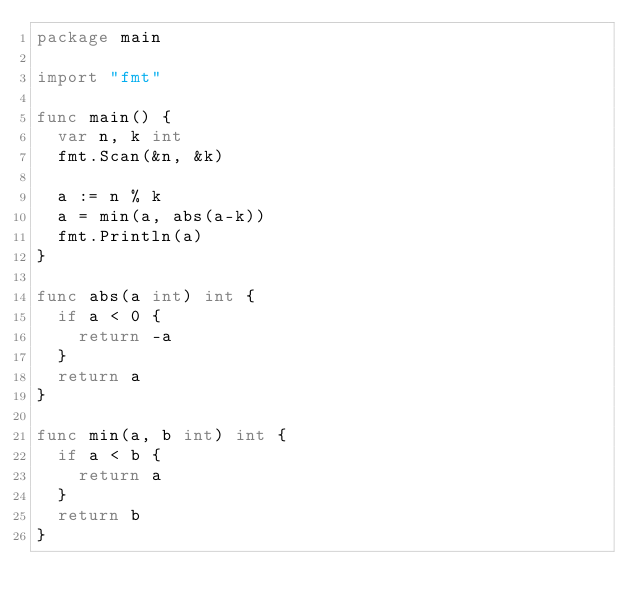Convert code to text. <code><loc_0><loc_0><loc_500><loc_500><_Go_>package main

import "fmt"

func main() {
	var n, k int
	fmt.Scan(&n, &k)

	a := n % k
	a = min(a, abs(a-k))
	fmt.Println(a)
}

func abs(a int) int {
	if a < 0 {
		return -a
	}
	return a
}

func min(a, b int) int {
	if a < b {
		return a
	}
	return b
}
</code> 